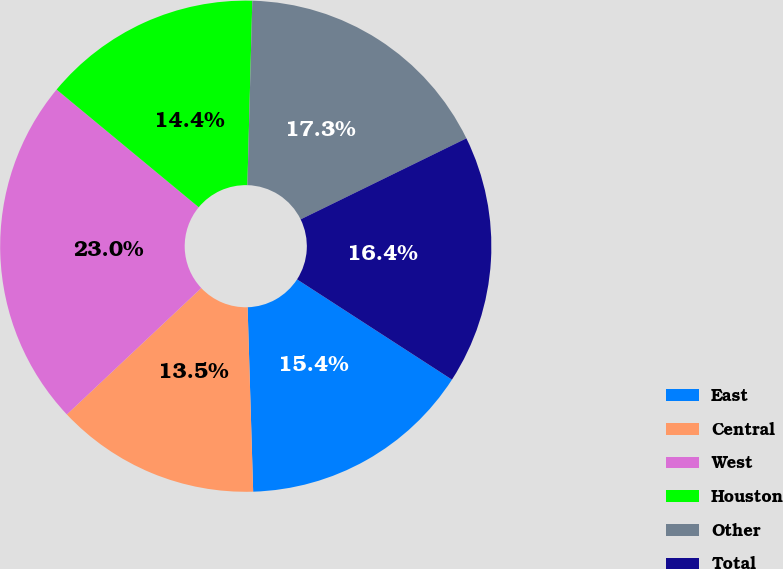<chart> <loc_0><loc_0><loc_500><loc_500><pie_chart><fcel>East<fcel>Central<fcel>West<fcel>Houston<fcel>Other<fcel>Total<nl><fcel>15.38%<fcel>13.47%<fcel>23.02%<fcel>14.42%<fcel>17.34%<fcel>16.38%<nl></chart> 